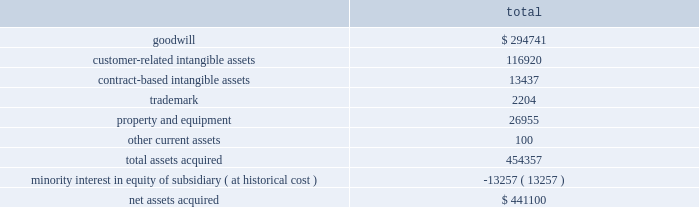Notes to consolidated financial statements 2014 ( continued ) merchant acquiring business in the united kingdom to the partnership .
In addition , hsbc uk entered into a ten-year marketing alliance with the partnership in which hsbc uk will refer customers to the partnership for payment processing services in the united kingdom .
On june 23 , 2008 , we entered into a new five year , $ 200 million term loan to fund a portion of the acquisition .
We funded the remaining purchase price with excess cash and our existing credit facilities .
The term loan bears interest , at our election , at the prime rate or london interbank offered rate plus a margin based on our leverage position .
As of july 1 , 2008 , the interest rate on the term loan was 3.605% ( 3.605 % ) .
The term loan calls for quarterly principal payments of $ 5 million beginning with the quarter ending august 31 , 2008 and increasing to $ 10 million beginning with the quarter ending august 31 , 2010 and $ 15 million beginning with the quarter ending august 31 , 2011 .
The partnership agreement includes provisions pursuant to which hsbc uk may compel us to purchase , at fair value , additional membership units from hsbc uk ( the 201cput option 201d ) .
Hsbc uk may exercise the put option on the fifth anniversary of the closing of the acquisition and on each anniversary thereafter .
By exercising the put option , hsbc uk can require us to purchase , on an annual basis , up to 15% ( 15 % ) of the total membership units .
Additionally , on the tenth anniversary of closing and each tenth anniversary thereafter , hsbc uk may compel us to purchase all of their membership units at fair value .
While not redeemable until june 2013 , we estimate the maximum total redemption amount of the minority interest under the put option would be $ 421.4 million , as of may 31 , 2008 .
The purpose of this acquisition was to establish a presence in the united kingdom .
The key factors that contributed to the decision to make this acquisition include historical and prospective financial statement analysis and hsbc uk 2019s market share and retail presence in the united kingdom .
The purchase price was determined by analyzing the historical and prospective financial statements and applying relevant purchase price multiples .
The purchase price totaled $ 441.1 million , consisting of $ 438.6 million cash consideration plus $ 2.5 million of direct out of pocket costs .
The acquisition has been recorded using the purchase method of accounting , and , accordingly , the purchase price has been allocated to the assets acquired and liabilities assumed based on their estimated fair values at the date of acquisition .
The table summarizes the preliminary purchase price allocation: .
Due to the recent timing of the transaction , the allocation of the purchase price is preliminary .
All of the goodwill associated with the acquisition is expected to be deductible for tax purposes .
The customer-related intangible assets have amortization periods of up to 13 years .
The contract-based intangible assets have amortization periods of 7 years .
The trademark has an amortization period of 5 years. .
What portion of the net assets acquired is dedicated for goodwill? 
Computations: (294741 / 441100)
Answer: 0.6682. 